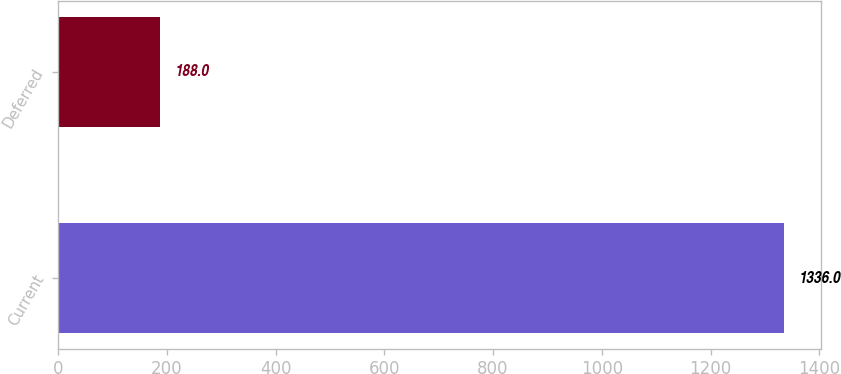Convert chart. <chart><loc_0><loc_0><loc_500><loc_500><bar_chart><fcel>Current<fcel>Deferred<nl><fcel>1336<fcel>188<nl></chart> 